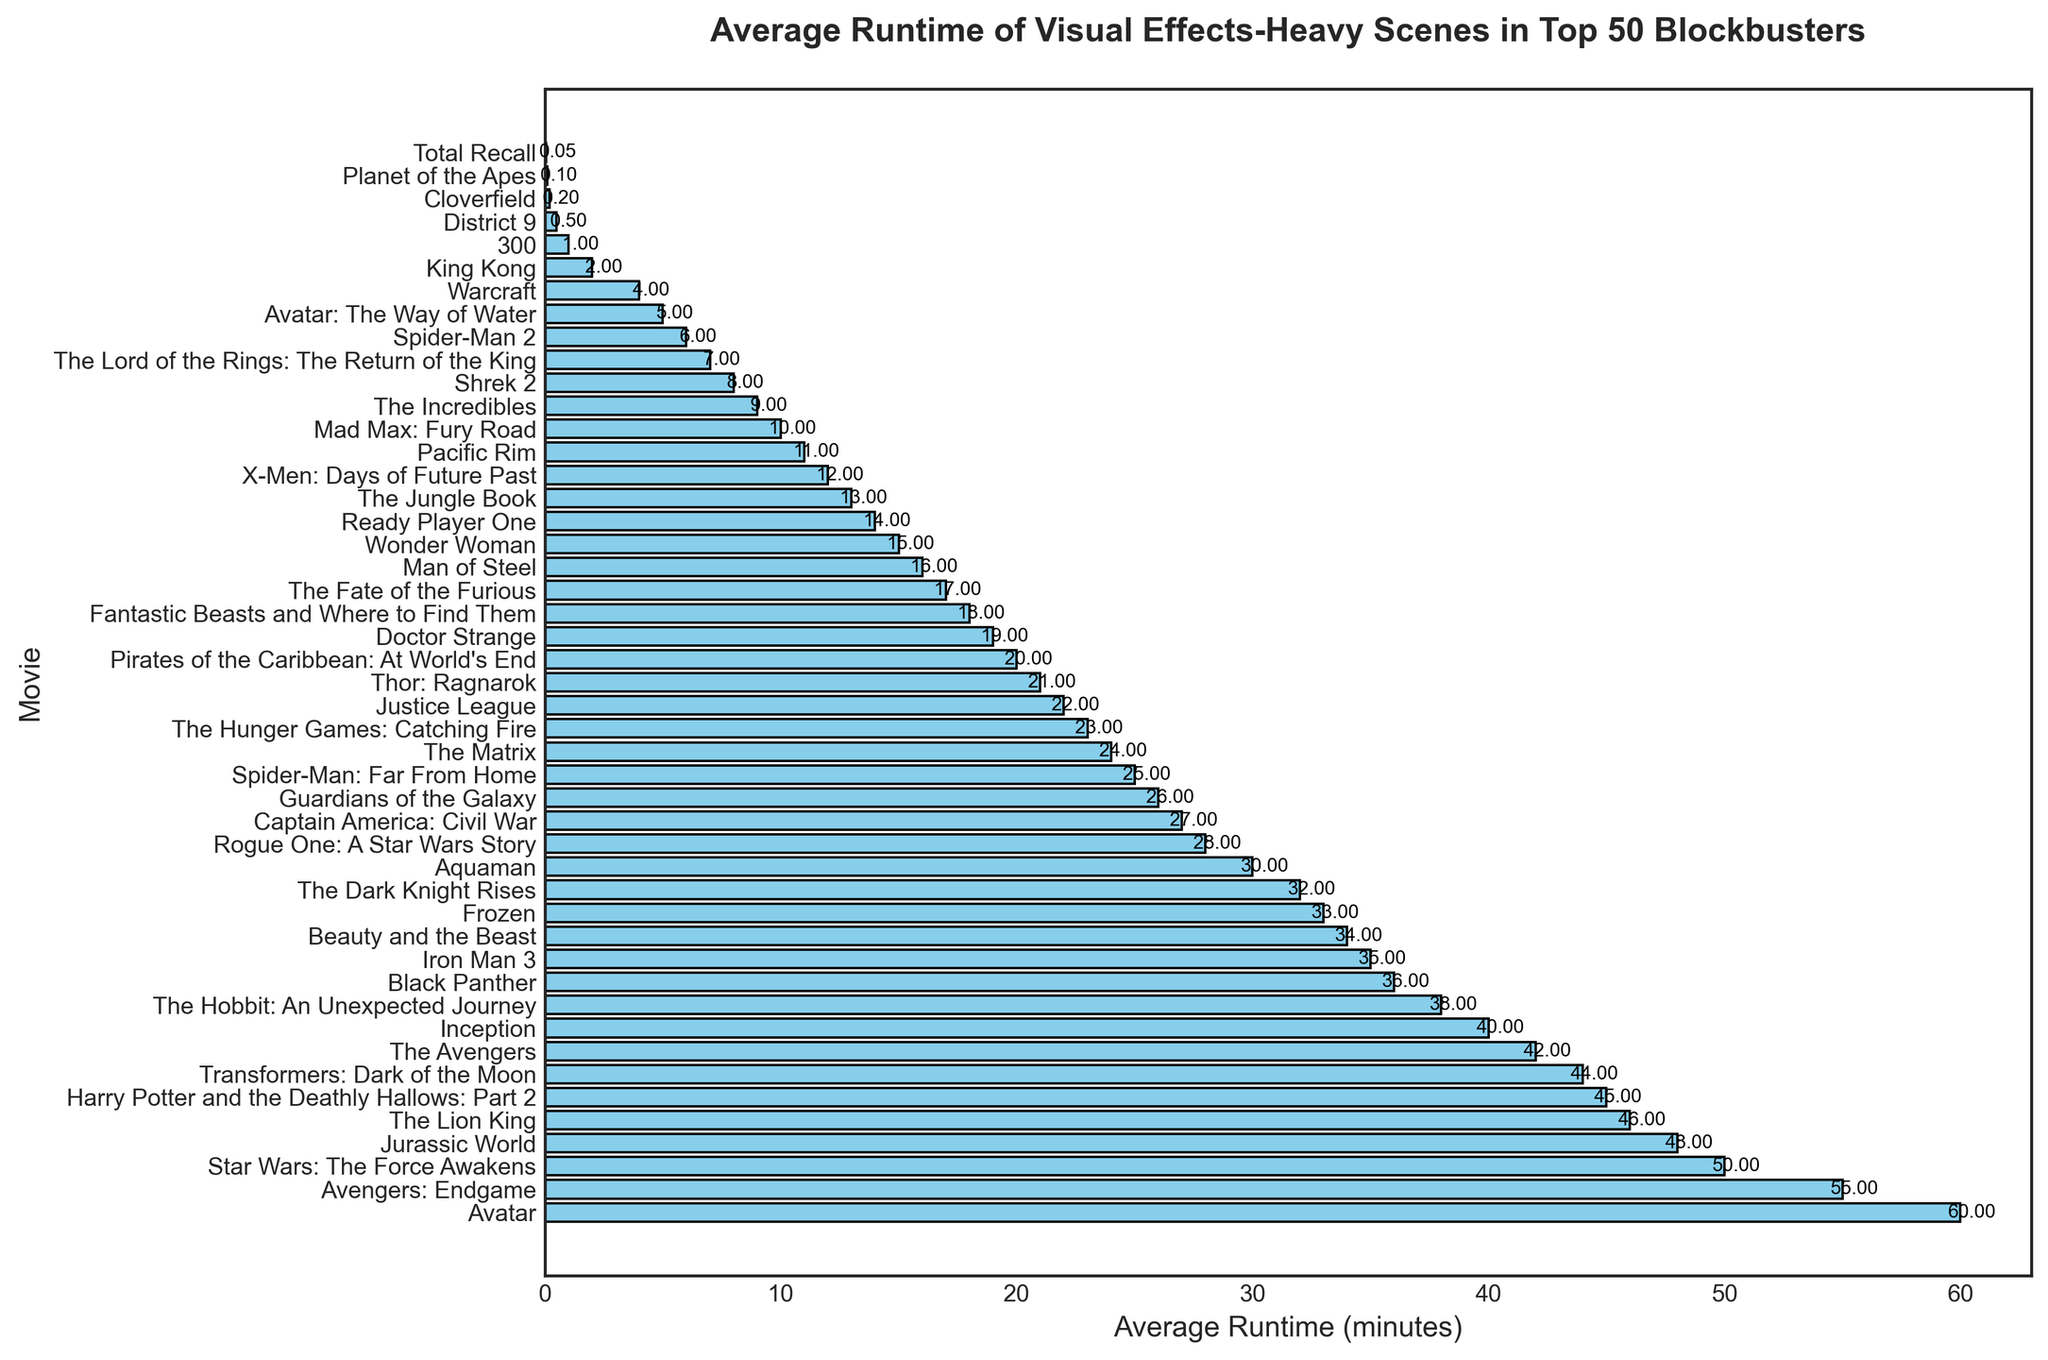What movie has the longest average runtime of VFX-heavy scenes? Look for the bar that has the highest value in terms of length.
Answer: Avatar Which movie has a longer average runtime of VFX scenes, Avengers: Endgame or The Hobbit: An Unexpected Journey? Compare the length of the bars for "Avengers: Endgame" and "The Hobbit: An Unexpected Journey."
Answer: Avengers: Endgame What is the combined average runtime of VFX scenes for Avatar and Transformers: Dark of the Moon? Sum the values of Avatar (60 minutes) and Transformers: Dark of the Moon (44 minutes). 60 + 44 = 104
Answer: 104 Which movie has the shortest average runtime of VFX-heavy scenes? Look for the bar with the shortest length.
Answer: Total Recall How much more average runtime of VFX scenes does Jurassic World have compared to Wonder Woman? Subtract the value for Wonder Woman (15 minutes) from the value for Jurassic World (48 minutes). 48 - 15 = 33
Answer: 33 What is the average runtime of VFX scenes for the top three movies with the highest VFX runtime? The top three movies are Avatar (60), Avengers: Endgame (55), and Star Wars: The Force Awakens (50). Calculate the average: (60 + 55 + 50) / 3 = 165 / 3 = 55
Answer: 55 Are there more movies with an average runtime of VFX scenes above or below 30 minutes? Count the number of bars above and below the 30-minute mark. There are 18 movies above and 32 below.
Answer: Below Which movie has an average runtime of VFX scenes closest to 25 minutes? Look for the bar with a value nearest to 25.
Answer: Spider-Man: Far From Home What is the total average runtime of VFX scenes for all movies combined? Sum the values of all the bars.
Answer: 690.85 Is the average runtime of VFX scenes in Captain America: Civil War greater than Doctor Strange? Compare the values of Captain America: Civil War (27 minutes) and Doctor Strange (19 minutes).
Answer: Yes 